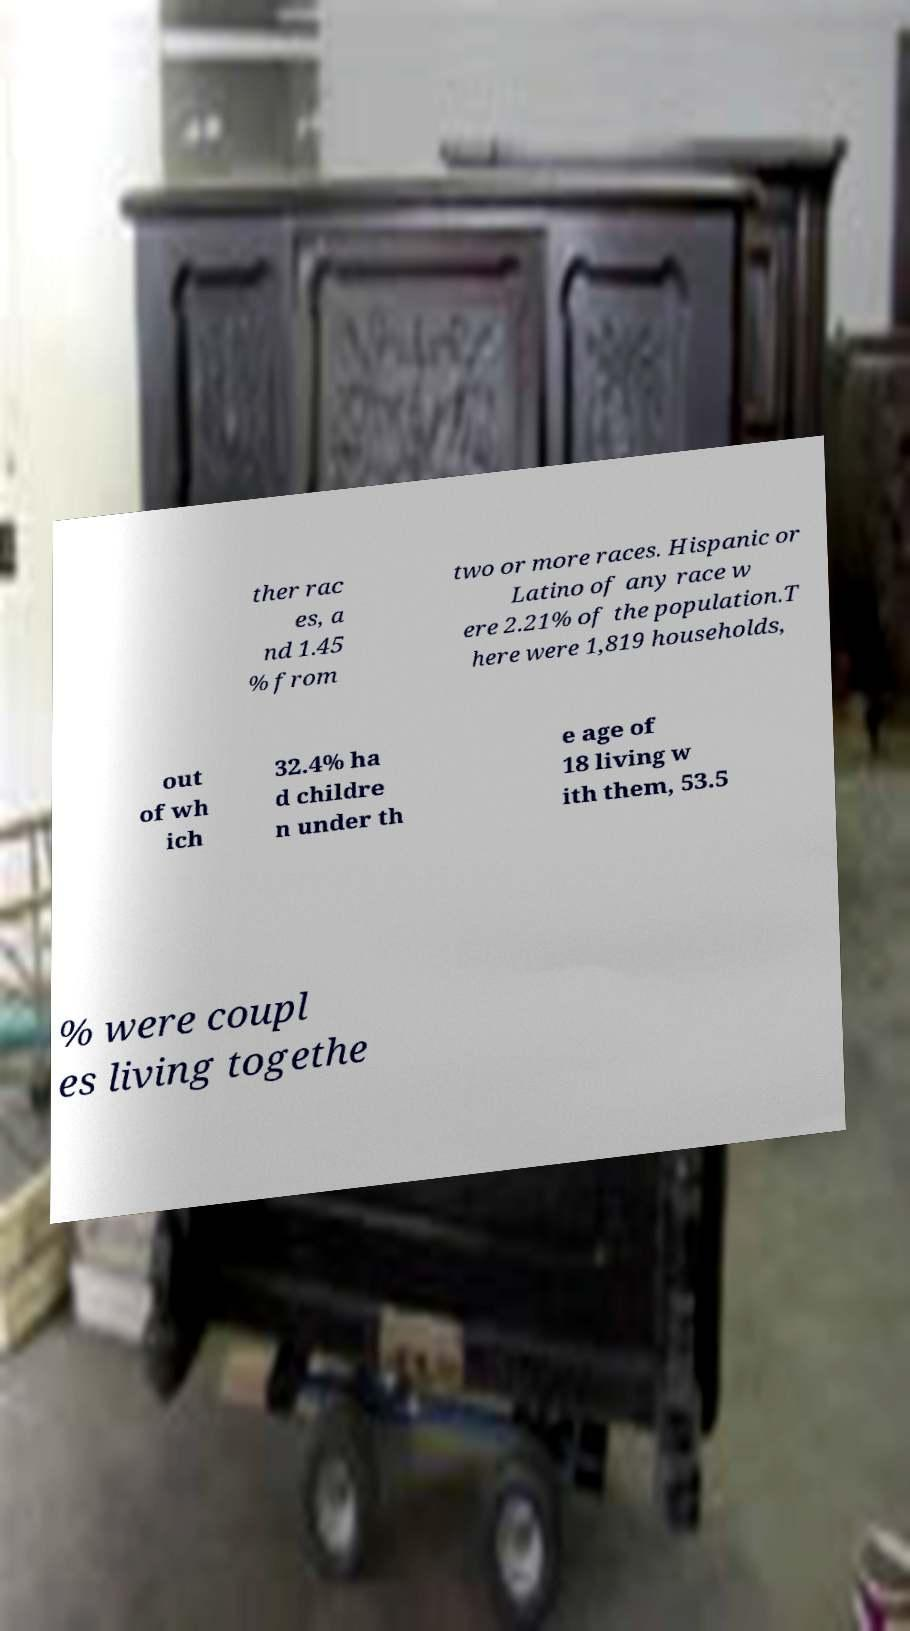Can you accurately transcribe the text from the provided image for me? ther rac es, a nd 1.45 % from two or more races. Hispanic or Latino of any race w ere 2.21% of the population.T here were 1,819 households, out of wh ich 32.4% ha d childre n under th e age of 18 living w ith them, 53.5 % were coupl es living togethe 